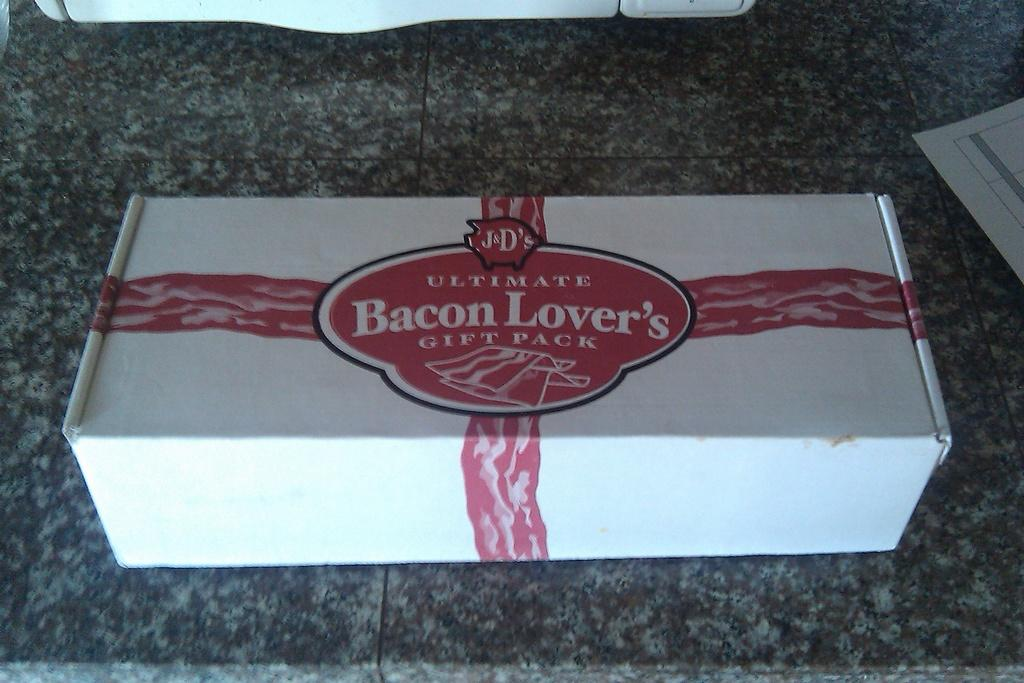What object is present on the countertop in the image? There is a box in the image. Where is the box located in the image? The box is placed on a countertop. What type of creature can be seen interacting with the box in the image? There is no creature present in the image; it only features a box placed on a countertop. What does the box taste like in the image? The image does not provide any information about the taste of the box, as it is not an edible object. 